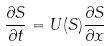Convert formula to latex. <formula><loc_0><loc_0><loc_500><loc_500>\frac { \partial S } { \partial t } = U ( S ) \frac { \partial S } { \partial x }</formula> 